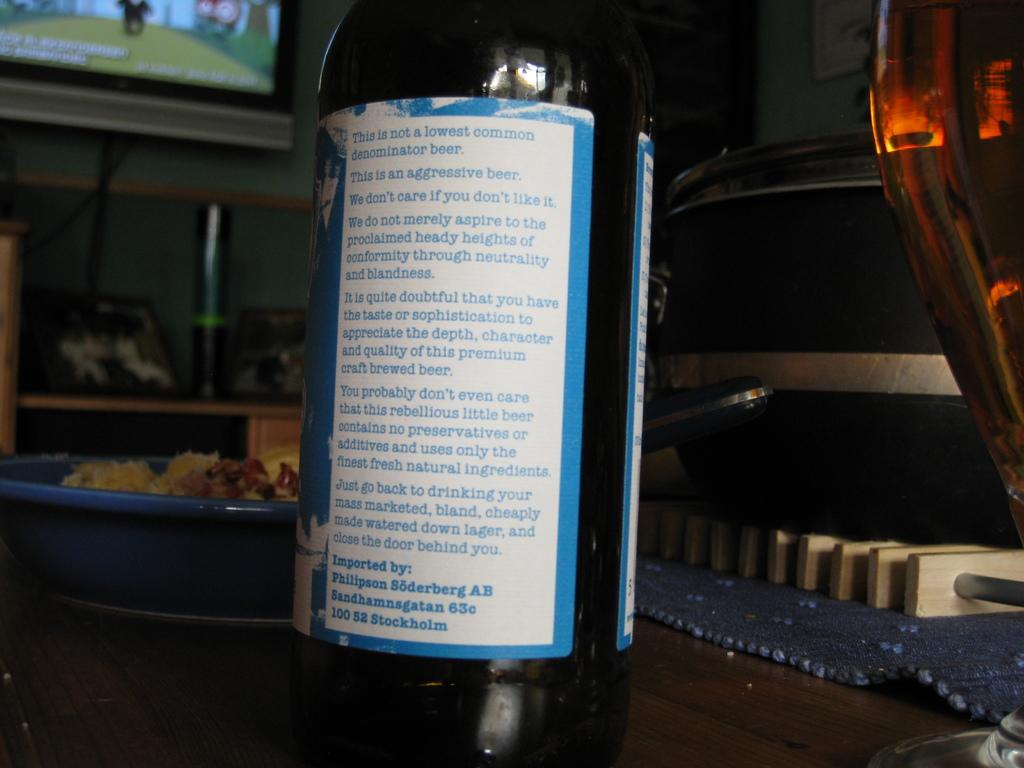Provide a one-sentence caption for the provided image. The back ingredients of a bottle from Stockholm. 